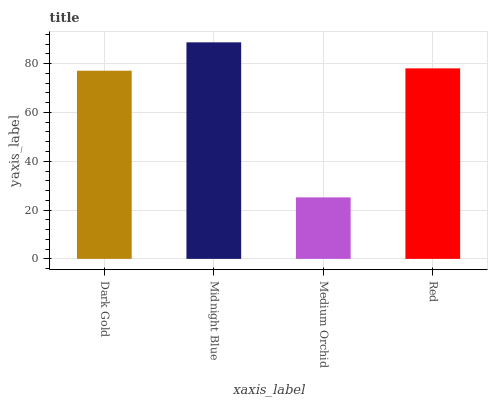Is Medium Orchid the minimum?
Answer yes or no. Yes. Is Midnight Blue the maximum?
Answer yes or no. Yes. Is Midnight Blue the minimum?
Answer yes or no. No. Is Medium Orchid the maximum?
Answer yes or no. No. Is Midnight Blue greater than Medium Orchid?
Answer yes or no. Yes. Is Medium Orchid less than Midnight Blue?
Answer yes or no. Yes. Is Medium Orchid greater than Midnight Blue?
Answer yes or no. No. Is Midnight Blue less than Medium Orchid?
Answer yes or no. No. Is Red the high median?
Answer yes or no. Yes. Is Dark Gold the low median?
Answer yes or no. Yes. Is Midnight Blue the high median?
Answer yes or no. No. Is Medium Orchid the low median?
Answer yes or no. No. 